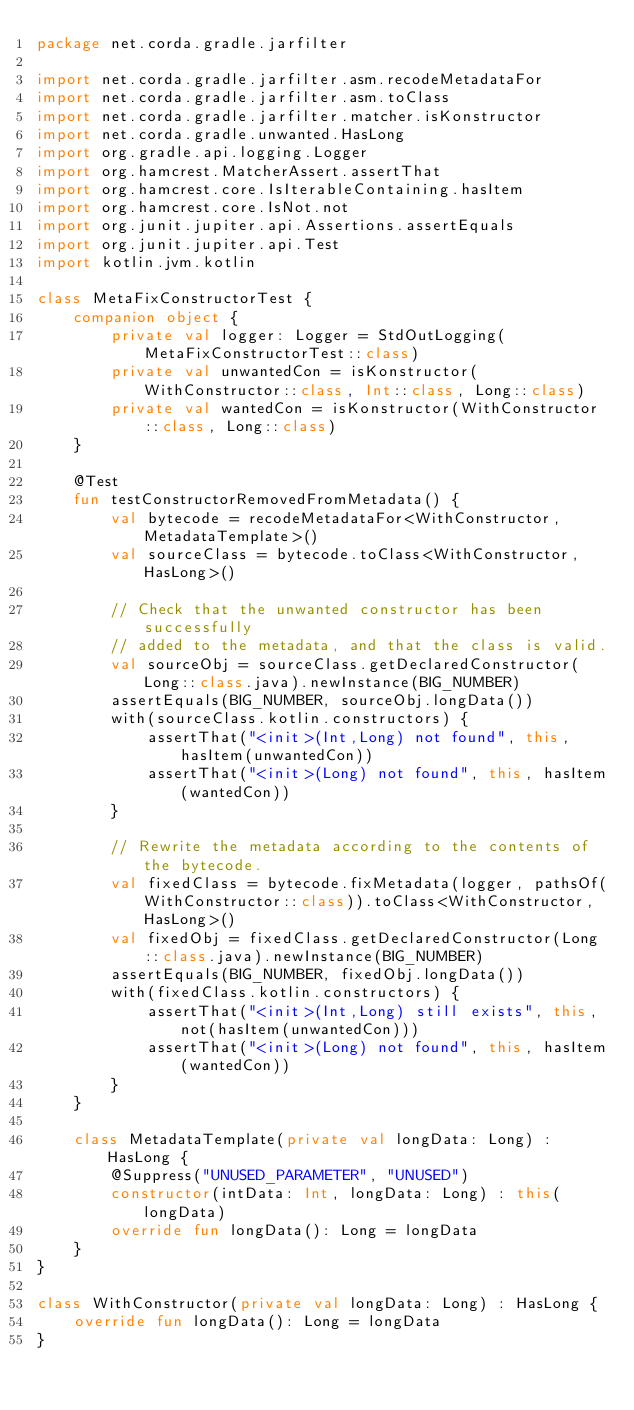<code> <loc_0><loc_0><loc_500><loc_500><_Kotlin_>package net.corda.gradle.jarfilter

import net.corda.gradle.jarfilter.asm.recodeMetadataFor
import net.corda.gradle.jarfilter.asm.toClass
import net.corda.gradle.jarfilter.matcher.isKonstructor
import net.corda.gradle.unwanted.HasLong
import org.gradle.api.logging.Logger
import org.hamcrest.MatcherAssert.assertThat
import org.hamcrest.core.IsIterableContaining.hasItem
import org.hamcrest.core.IsNot.not
import org.junit.jupiter.api.Assertions.assertEquals
import org.junit.jupiter.api.Test
import kotlin.jvm.kotlin

class MetaFixConstructorTest {
    companion object {
        private val logger: Logger = StdOutLogging(MetaFixConstructorTest::class)
        private val unwantedCon = isKonstructor(WithConstructor::class, Int::class, Long::class)
        private val wantedCon = isKonstructor(WithConstructor::class, Long::class)
    }

    @Test
    fun testConstructorRemovedFromMetadata() {
        val bytecode = recodeMetadataFor<WithConstructor, MetadataTemplate>()
        val sourceClass = bytecode.toClass<WithConstructor, HasLong>()

        // Check that the unwanted constructor has been successfully
        // added to the metadata, and that the class is valid.
        val sourceObj = sourceClass.getDeclaredConstructor(Long::class.java).newInstance(BIG_NUMBER)
        assertEquals(BIG_NUMBER, sourceObj.longData())
        with(sourceClass.kotlin.constructors) {
            assertThat("<init>(Int,Long) not found", this, hasItem(unwantedCon))
            assertThat("<init>(Long) not found", this, hasItem(wantedCon))
        }

        // Rewrite the metadata according to the contents of the bytecode.
        val fixedClass = bytecode.fixMetadata(logger, pathsOf(WithConstructor::class)).toClass<WithConstructor, HasLong>()
        val fixedObj = fixedClass.getDeclaredConstructor(Long::class.java).newInstance(BIG_NUMBER)
        assertEquals(BIG_NUMBER, fixedObj.longData())
        with(fixedClass.kotlin.constructors) {
            assertThat("<init>(Int,Long) still exists", this, not(hasItem(unwantedCon)))
            assertThat("<init>(Long) not found", this, hasItem(wantedCon))
        }
    }

    class MetadataTemplate(private val longData: Long) : HasLong {
        @Suppress("UNUSED_PARAMETER", "UNUSED")
        constructor(intData: Int, longData: Long) : this(longData)
        override fun longData(): Long = longData
    }
}

class WithConstructor(private val longData: Long) : HasLong {
    override fun longData(): Long = longData
}
</code> 